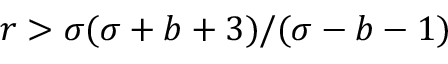Convert formula to latex. <formula><loc_0><loc_0><loc_500><loc_500>r > \sigma ( \sigma + b + 3 ) / ( \sigma - b - 1 )</formula> 